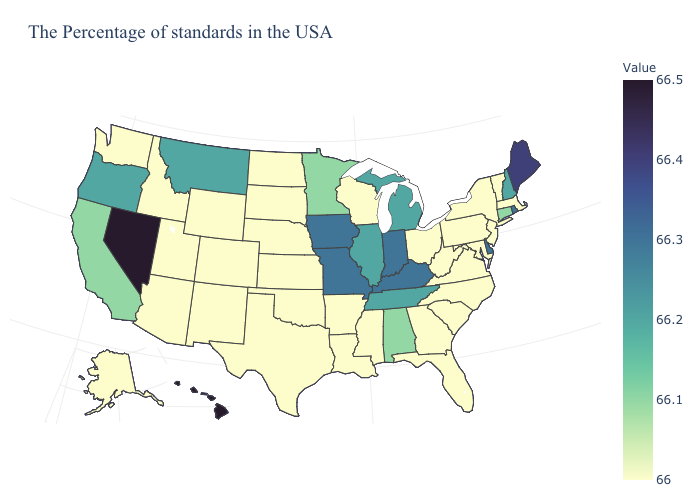Does Wyoming have the lowest value in the West?
Write a very short answer. Yes. Does Hawaii have the highest value in the USA?
Write a very short answer. Yes. Which states have the lowest value in the USA?
Short answer required. Massachusetts, Vermont, New York, New Jersey, Maryland, Pennsylvania, Virginia, North Carolina, South Carolina, West Virginia, Ohio, Florida, Georgia, Wisconsin, Mississippi, Louisiana, Arkansas, Kansas, Nebraska, Oklahoma, Texas, South Dakota, North Dakota, Wyoming, Colorado, New Mexico, Utah, Arizona, Idaho, Washington, Alaska. Among the states that border California , does Nevada have the highest value?
Answer briefly. Yes. 